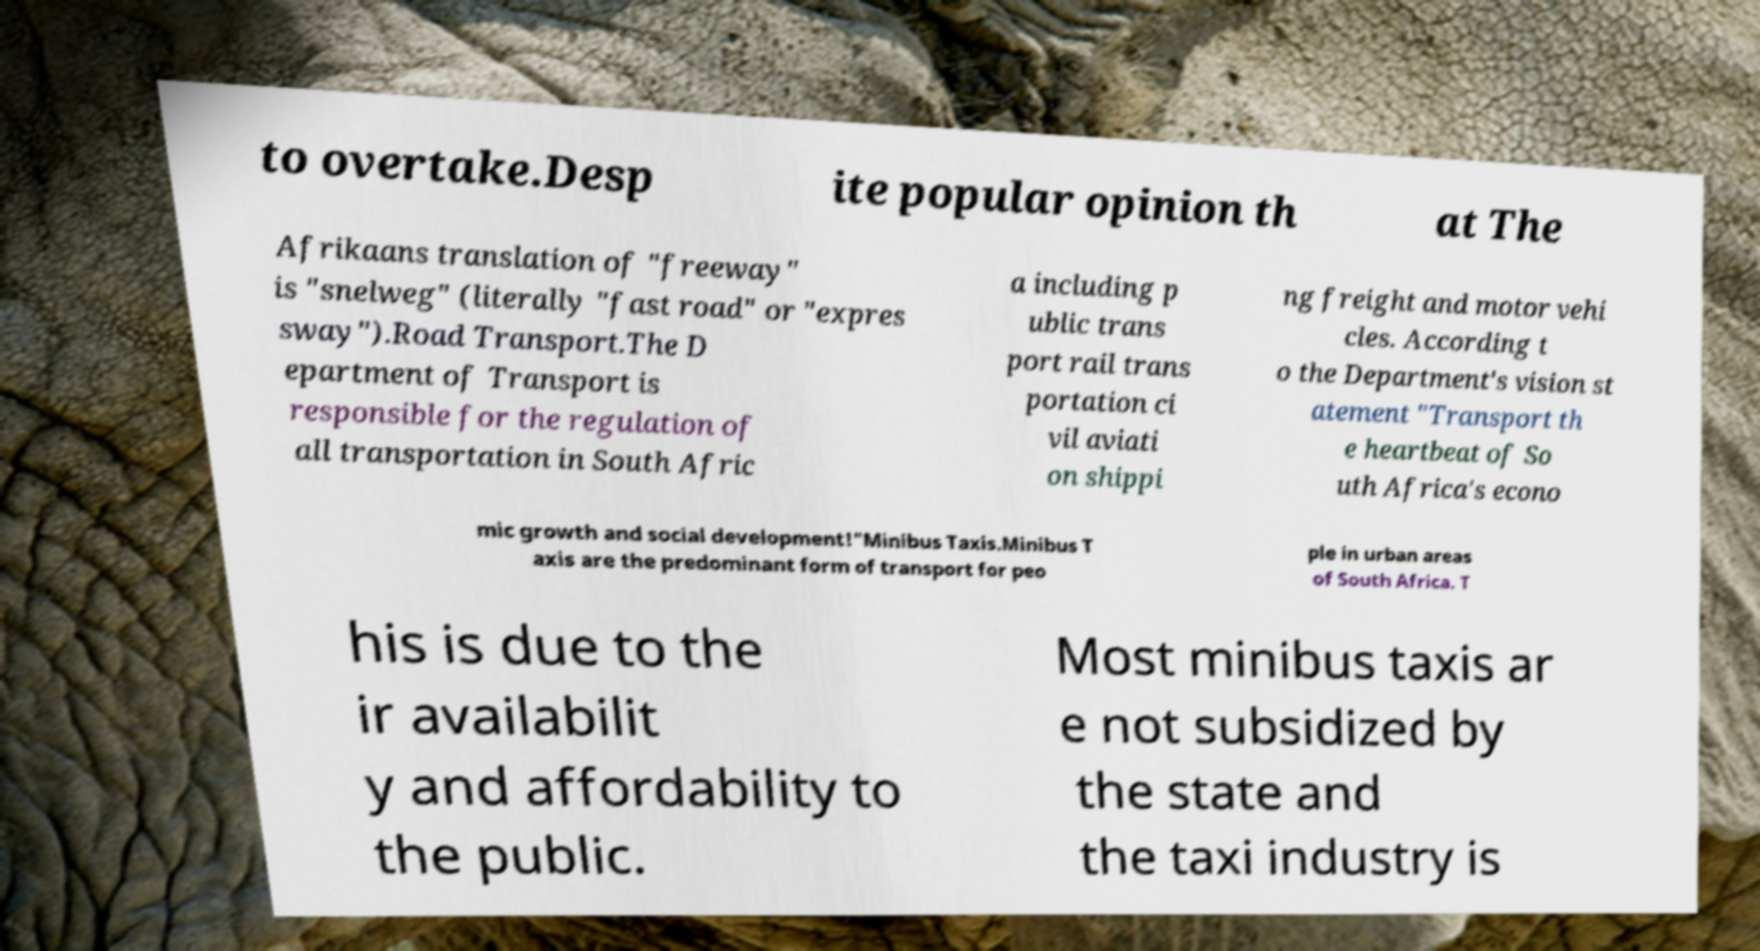Could you assist in decoding the text presented in this image and type it out clearly? to overtake.Desp ite popular opinion th at The Afrikaans translation of "freeway" is "snelweg" (literally "fast road" or "expres sway").Road Transport.The D epartment of Transport is responsible for the regulation of all transportation in South Afric a including p ublic trans port rail trans portation ci vil aviati on shippi ng freight and motor vehi cles. According t o the Department's vision st atement "Transport th e heartbeat of So uth Africa's econo mic growth and social development!"Minibus Taxis.Minibus T axis are the predominant form of transport for peo ple in urban areas of South Africa. T his is due to the ir availabilit y and affordability to the public. Most minibus taxis ar e not subsidized by the state and the taxi industry is 